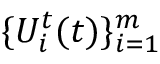Convert formula to latex. <formula><loc_0><loc_0><loc_500><loc_500>\{ U _ { i } ^ { t } ( t ) \} _ { i = 1 } ^ { m }</formula> 